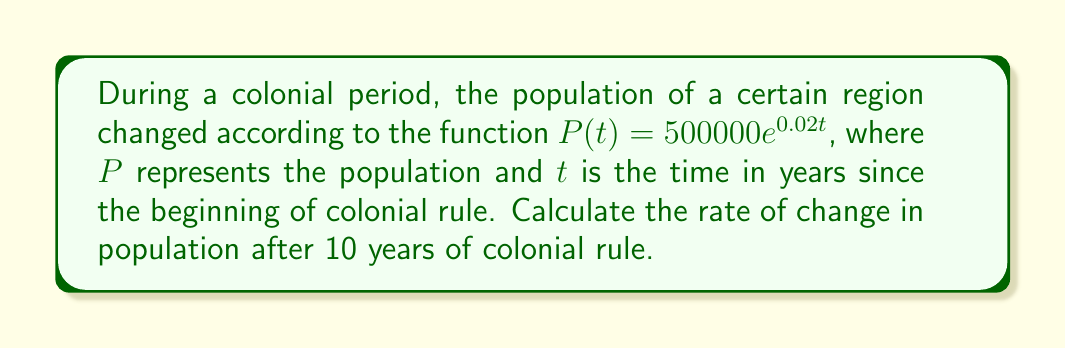Provide a solution to this math problem. To solve this problem, we need to follow these steps:

1) The function given is $P(t) = 500000e^{0.02t}$

2) To find the rate of change, we need to differentiate this function with respect to t:

   $$\frac{dP}{dt} = 500000 \cdot 0.02e^{0.02t} = 10000e^{0.02t}$$

3) This derivative represents the instantaneous rate of change of the population at any time t.

4) We're asked to find the rate of change after 10 years, so we need to evaluate this derivative at t = 10:

   $$\frac{dP}{dt}\bigg|_{t=10} = 10000e^{0.02(10)}$$

5) Let's calculate this:
   
   $$10000e^{0.2} \approx 12214.03$$

6) This result represents the number of people by which the population is increasing per year at t = 10.
Answer: The rate of change in population after 10 years of colonial rule is approximately 12,214 people per year. 